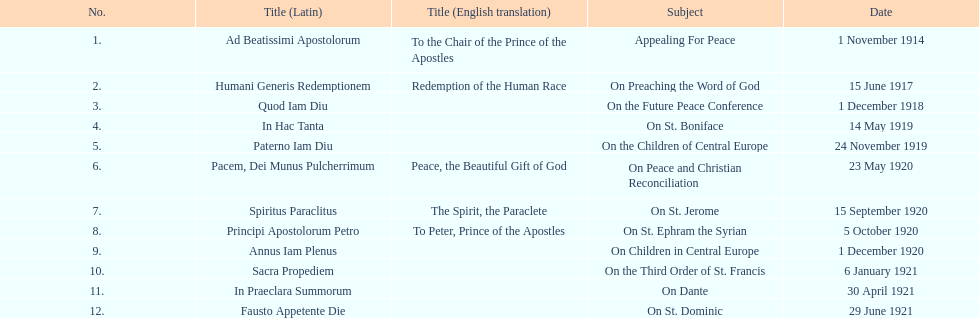What is the subject listed after appealing for peace? On Preaching the Word of God. 